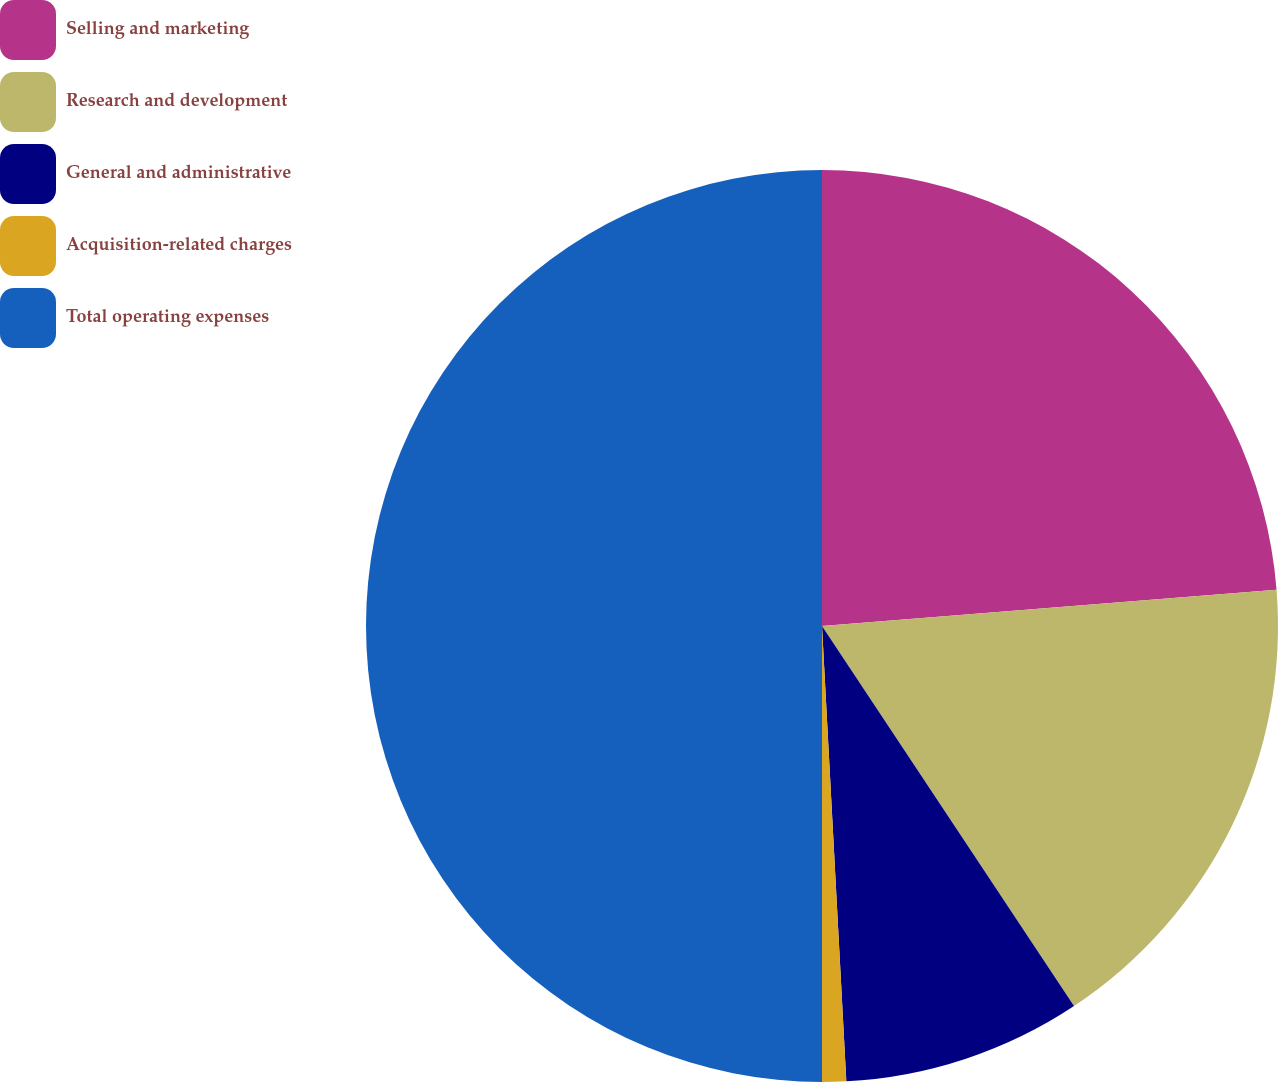Convert chart to OTSL. <chart><loc_0><loc_0><loc_500><loc_500><pie_chart><fcel>Selling and marketing<fcel>Research and development<fcel>General and administrative<fcel>Acquisition-related charges<fcel>Total operating expenses<nl><fcel>23.73%<fcel>16.95%<fcel>8.47%<fcel>0.85%<fcel>50.0%<nl></chart> 